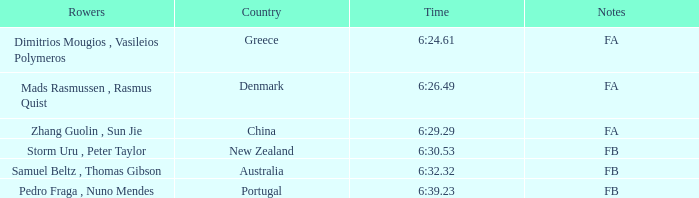What is the names of the rowers that the time was 6:24.61? Dimitrios Mougios , Vasileios Polymeros. 